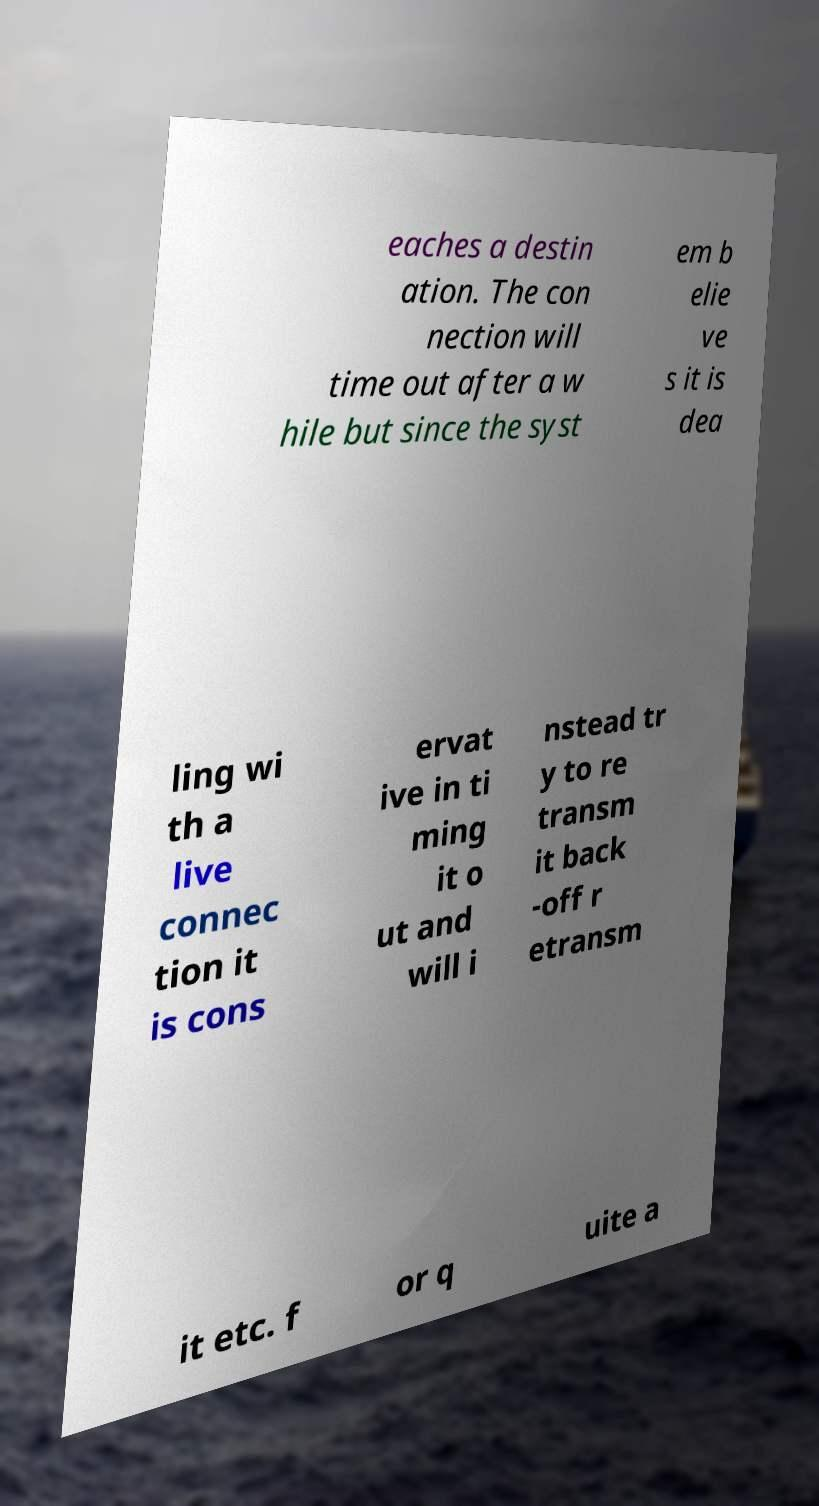What messages or text are displayed in this image? I need them in a readable, typed format. eaches a destin ation. The con nection will time out after a w hile but since the syst em b elie ve s it is dea ling wi th a live connec tion it is cons ervat ive in ti ming it o ut and will i nstead tr y to re transm it back -off r etransm it etc. f or q uite a 